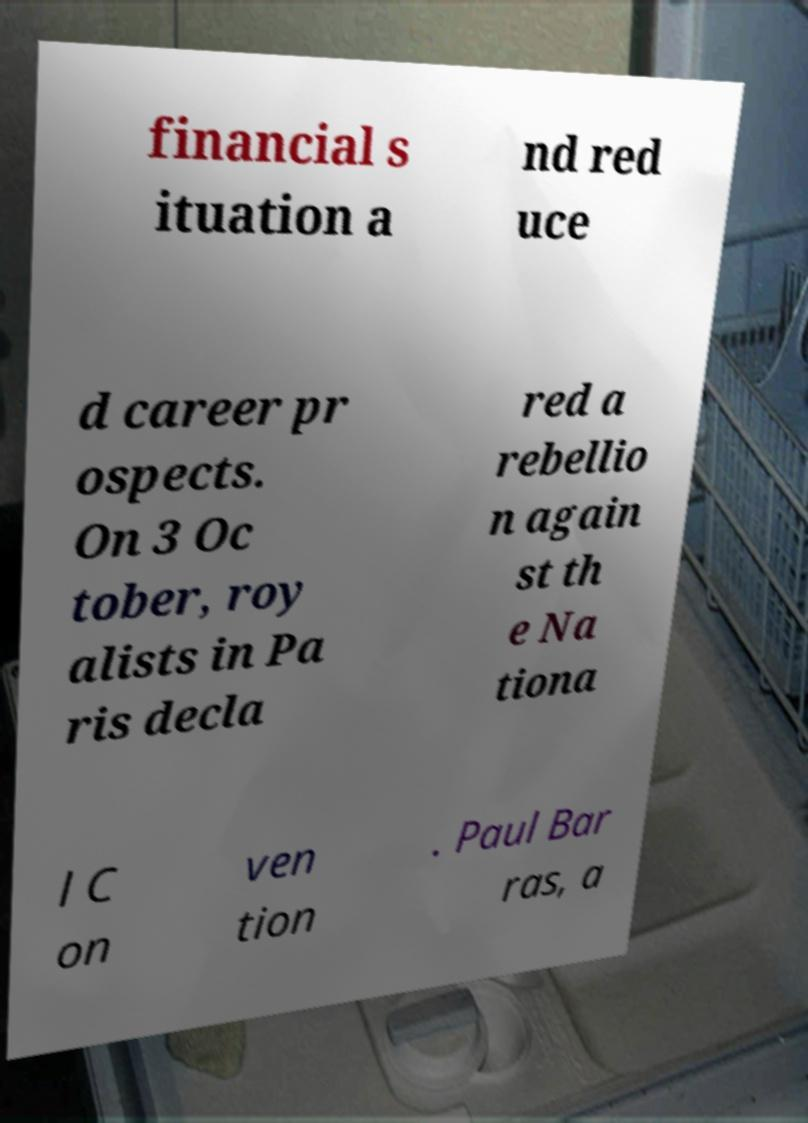What messages or text are displayed in this image? I need them in a readable, typed format. financial s ituation a nd red uce d career pr ospects. On 3 Oc tober, roy alists in Pa ris decla red a rebellio n again st th e Na tiona l C on ven tion . Paul Bar ras, a 